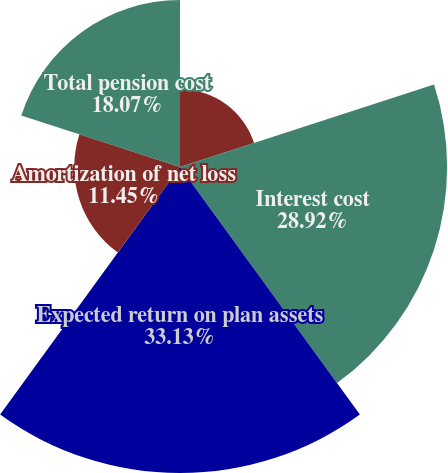Convert chart. <chart><loc_0><loc_0><loc_500><loc_500><pie_chart><fcel>Service cost<fcel>Interest cost<fcel>Expected return on plan assets<fcel>Amortization of net loss<fcel>Total pension cost<nl><fcel>8.43%<fcel>28.92%<fcel>33.13%<fcel>11.45%<fcel>18.07%<nl></chart> 